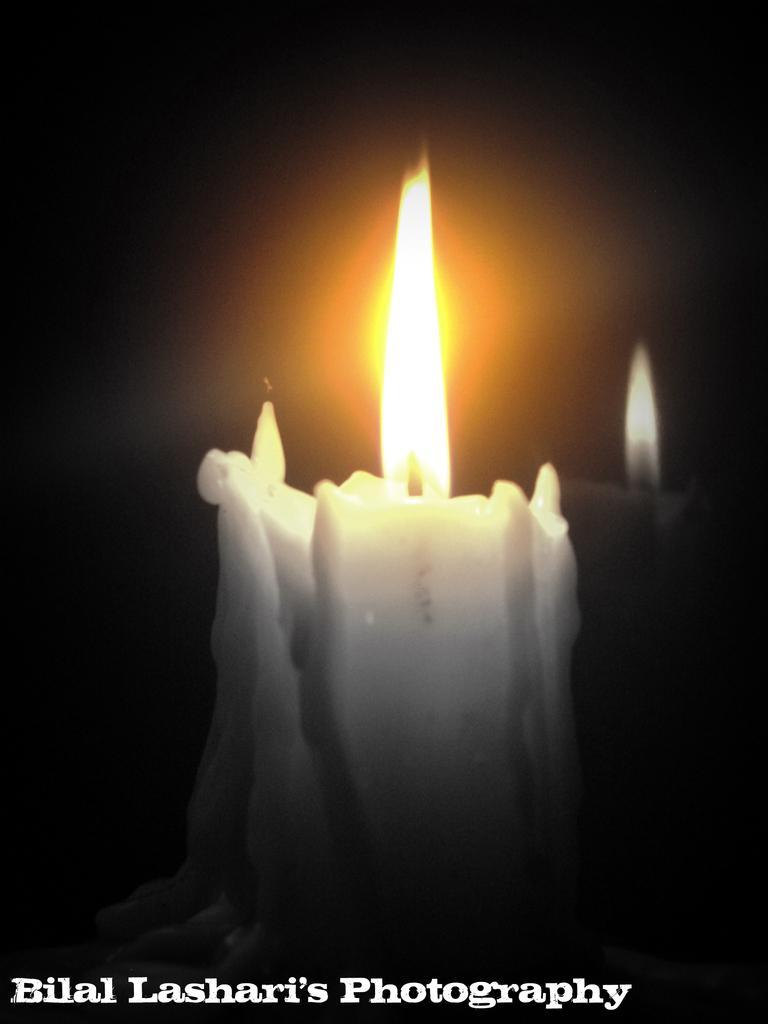Please provide a concise description of this image. There is a candle in the center of the image and text at the bottom side. 